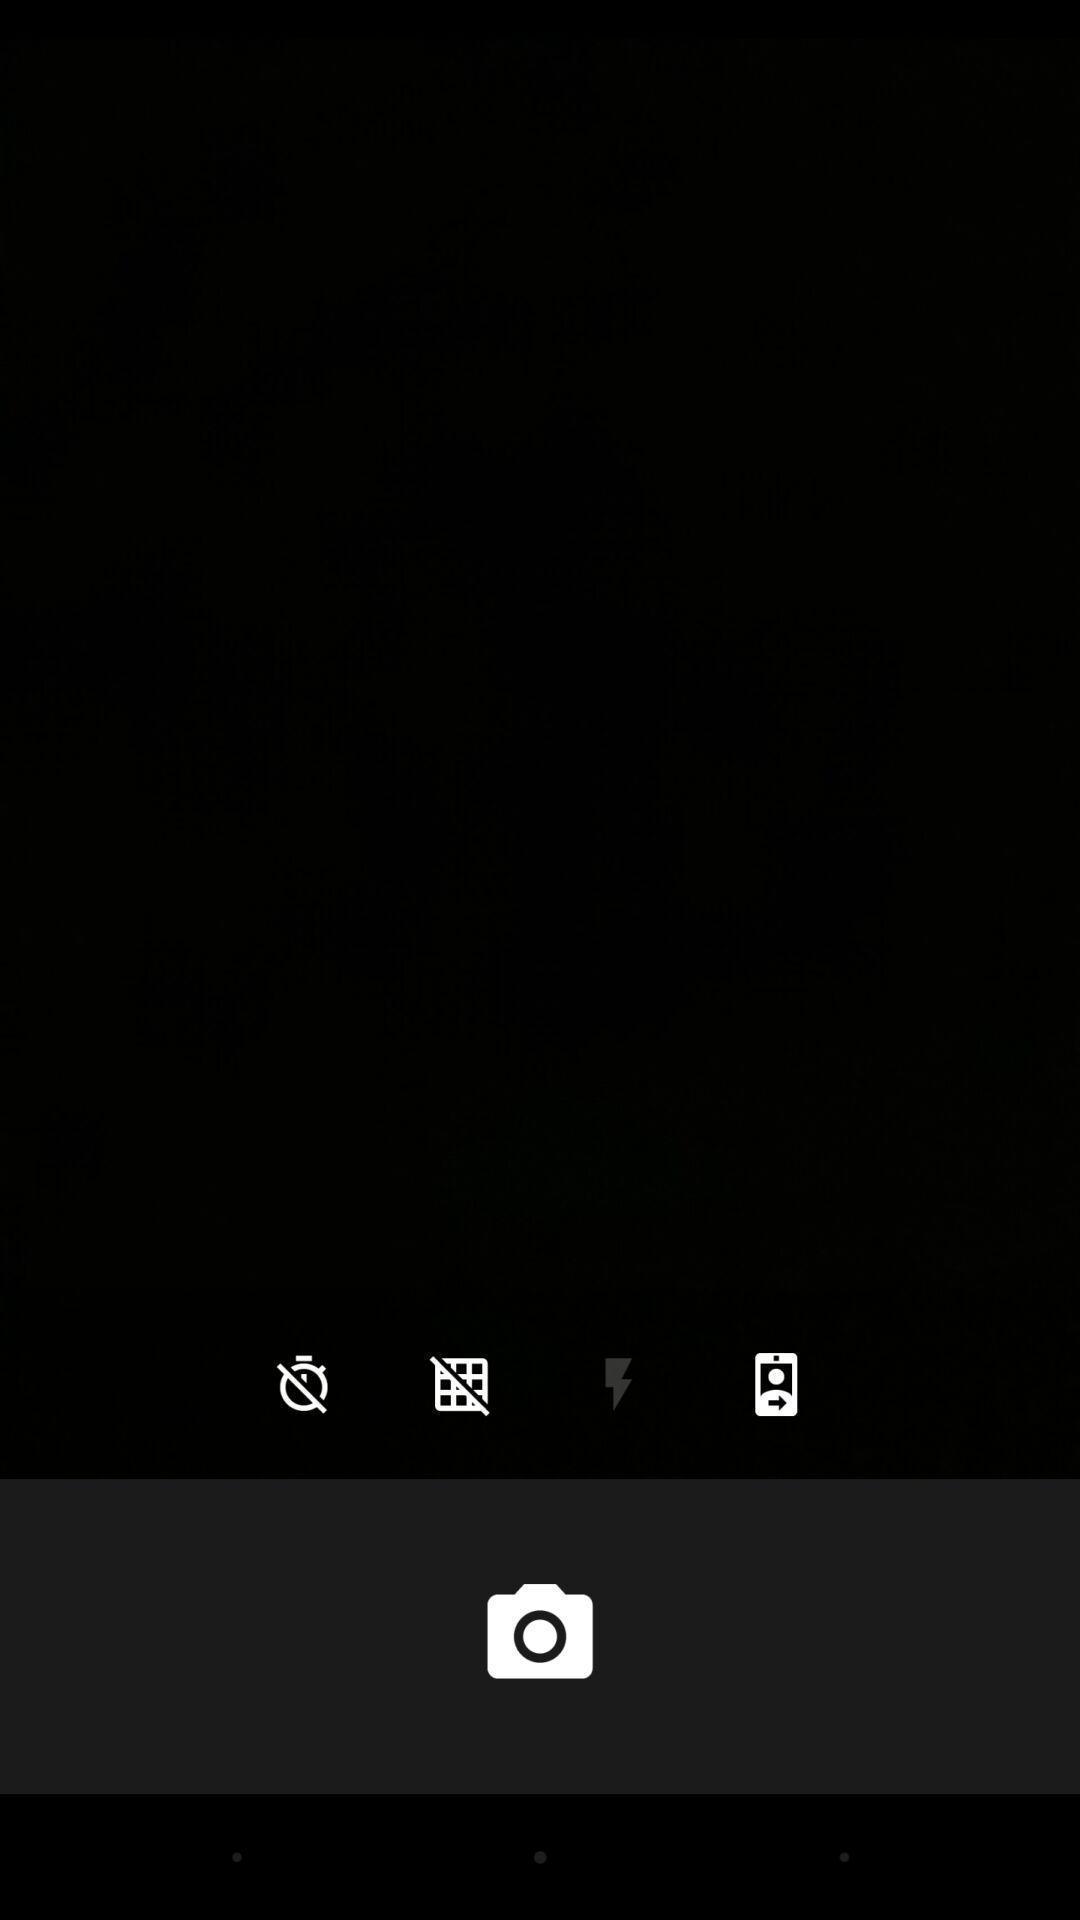Give me a summary of this screen capture. Screen shows camera icon with multiple options. 